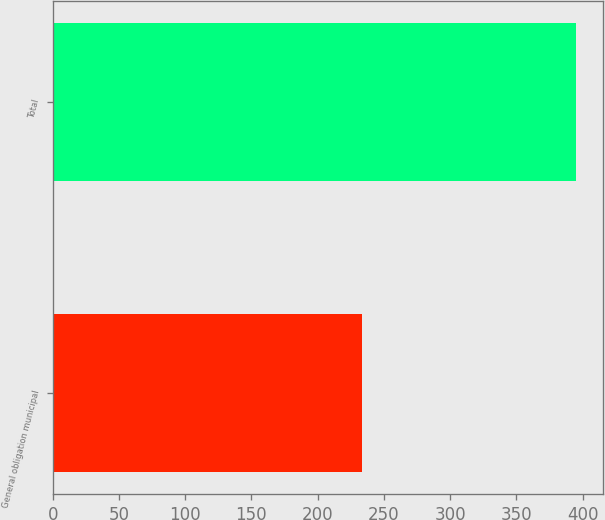<chart> <loc_0><loc_0><loc_500><loc_500><bar_chart><fcel>General obligation municipal<fcel>Total<nl><fcel>233.6<fcel>395.2<nl></chart> 